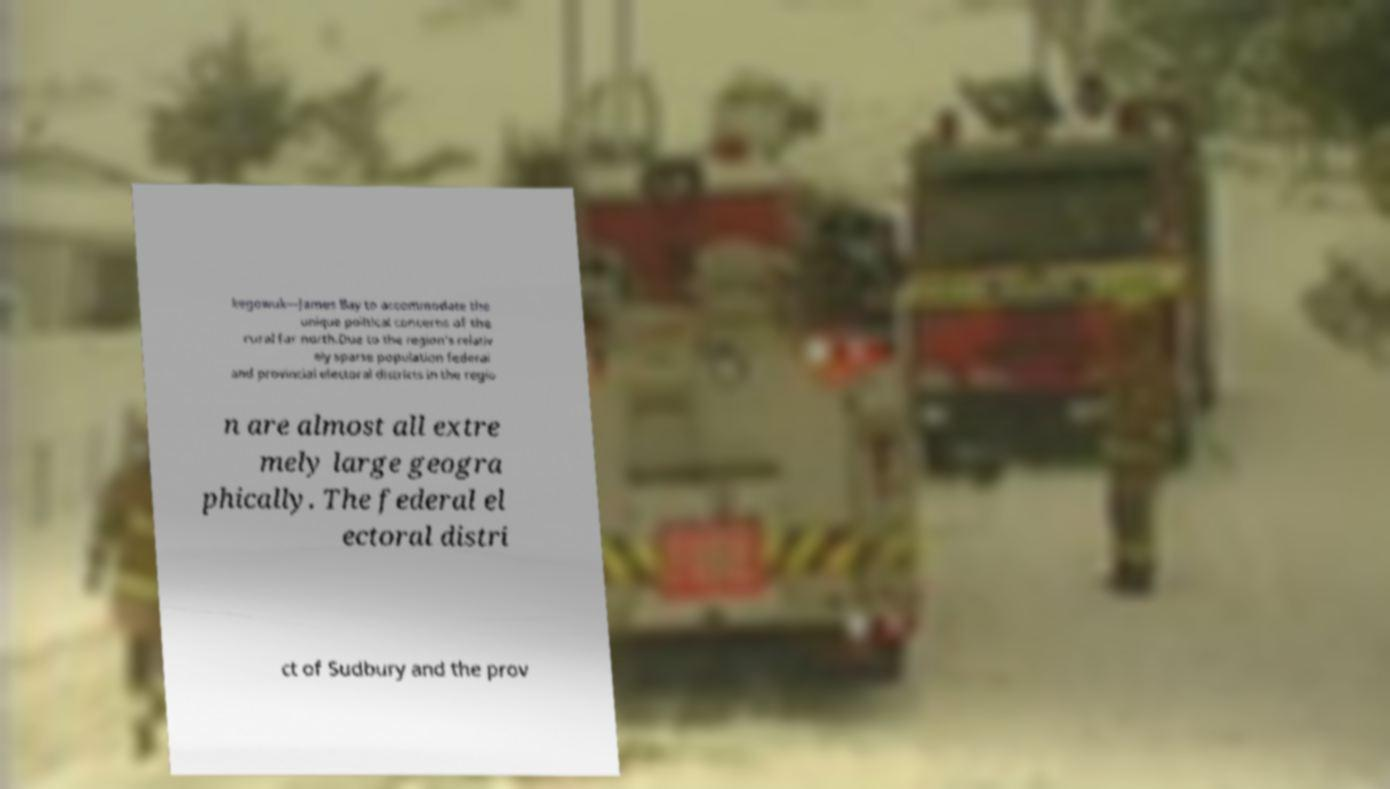For documentation purposes, I need the text within this image transcribed. Could you provide that? kegowuk—James Bay to accommodate the unique political concerns of the rural far north.Due to the region's relativ ely sparse population federal and provincial electoral districts in the regio n are almost all extre mely large geogra phically. The federal el ectoral distri ct of Sudbury and the prov 